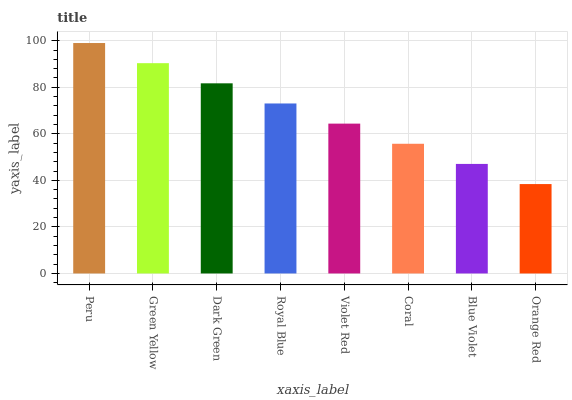Is Orange Red the minimum?
Answer yes or no. Yes. Is Peru the maximum?
Answer yes or no. Yes. Is Green Yellow the minimum?
Answer yes or no. No. Is Green Yellow the maximum?
Answer yes or no. No. Is Peru greater than Green Yellow?
Answer yes or no. Yes. Is Green Yellow less than Peru?
Answer yes or no. Yes. Is Green Yellow greater than Peru?
Answer yes or no. No. Is Peru less than Green Yellow?
Answer yes or no. No. Is Royal Blue the high median?
Answer yes or no. Yes. Is Violet Red the low median?
Answer yes or no. Yes. Is Violet Red the high median?
Answer yes or no. No. Is Orange Red the low median?
Answer yes or no. No. 